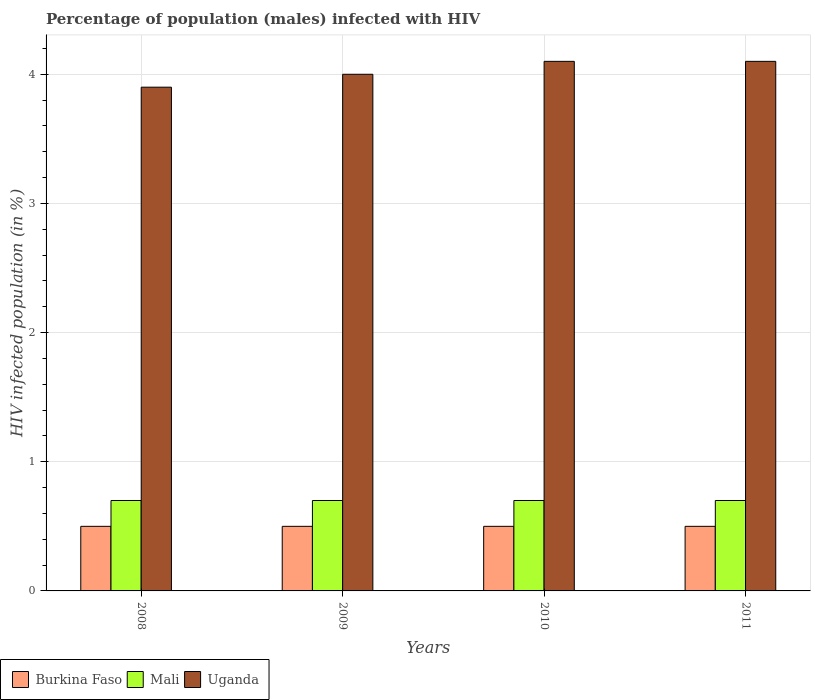How many different coloured bars are there?
Offer a terse response. 3. What is the label of the 3rd group of bars from the left?
Make the answer very short. 2010. In how many cases, is the number of bars for a given year not equal to the number of legend labels?
Provide a short and direct response. 0. What is the percentage of HIV infected male population in Uganda in 2008?
Offer a terse response. 3.9. Across all years, what is the maximum percentage of HIV infected male population in Burkina Faso?
Your answer should be compact. 0.5. What is the total percentage of HIV infected male population in Burkina Faso in the graph?
Make the answer very short. 2. What is the difference between the percentage of HIV infected male population in Burkina Faso in 2008 and the percentage of HIV infected male population in Uganda in 2010?
Make the answer very short. -3.6. What is the average percentage of HIV infected male population in Mali per year?
Offer a very short reply. 0.7. In the year 2010, what is the difference between the percentage of HIV infected male population in Burkina Faso and percentage of HIV infected male population in Mali?
Provide a succinct answer. -0.2. Is the percentage of HIV infected male population in Uganda in 2009 less than that in 2011?
Your answer should be compact. Yes. Is the difference between the percentage of HIV infected male population in Burkina Faso in 2010 and 2011 greater than the difference between the percentage of HIV infected male population in Mali in 2010 and 2011?
Offer a terse response. No. In how many years, is the percentage of HIV infected male population in Mali greater than the average percentage of HIV infected male population in Mali taken over all years?
Make the answer very short. 0. Is the sum of the percentage of HIV infected male population in Burkina Faso in 2009 and 2010 greater than the maximum percentage of HIV infected male population in Mali across all years?
Your answer should be very brief. Yes. What does the 1st bar from the left in 2009 represents?
Your answer should be compact. Burkina Faso. What does the 3rd bar from the right in 2011 represents?
Ensure brevity in your answer.  Burkina Faso. How many bars are there?
Provide a short and direct response. 12. Are all the bars in the graph horizontal?
Give a very brief answer. No. Does the graph contain any zero values?
Provide a short and direct response. No. Does the graph contain grids?
Keep it short and to the point. Yes. How many legend labels are there?
Your answer should be compact. 3. What is the title of the graph?
Make the answer very short. Percentage of population (males) infected with HIV. What is the label or title of the X-axis?
Offer a very short reply. Years. What is the label or title of the Y-axis?
Offer a terse response. HIV infected population (in %). What is the HIV infected population (in %) of Mali in 2008?
Make the answer very short. 0.7. What is the HIV infected population (in %) of Uganda in 2008?
Make the answer very short. 3.9. What is the HIV infected population (in %) in Burkina Faso in 2009?
Make the answer very short. 0.5. What is the HIV infected population (in %) in Mali in 2009?
Keep it short and to the point. 0.7. What is the HIV infected population (in %) in Uganda in 2009?
Provide a succinct answer. 4. What is the HIV infected population (in %) of Mali in 2010?
Offer a terse response. 0.7. What is the HIV infected population (in %) in Uganda in 2010?
Offer a very short reply. 4.1. What is the HIV infected population (in %) in Uganda in 2011?
Offer a terse response. 4.1. Across all years, what is the maximum HIV infected population (in %) of Burkina Faso?
Make the answer very short. 0.5. Across all years, what is the maximum HIV infected population (in %) in Mali?
Your answer should be compact. 0.7. Across all years, what is the minimum HIV infected population (in %) of Uganda?
Your answer should be very brief. 3.9. What is the total HIV infected population (in %) of Burkina Faso in the graph?
Provide a short and direct response. 2. What is the difference between the HIV infected population (in %) in Uganda in 2008 and that in 2009?
Provide a succinct answer. -0.1. What is the difference between the HIV infected population (in %) in Mali in 2008 and that in 2010?
Your answer should be very brief. 0. What is the difference between the HIV infected population (in %) of Uganda in 2008 and that in 2010?
Your answer should be compact. -0.2. What is the difference between the HIV infected population (in %) of Mali in 2008 and that in 2011?
Your response must be concise. 0. What is the difference between the HIV infected population (in %) of Uganda in 2008 and that in 2011?
Make the answer very short. -0.2. What is the difference between the HIV infected population (in %) of Burkina Faso in 2009 and that in 2010?
Provide a short and direct response. 0. What is the difference between the HIV infected population (in %) of Mali in 2009 and that in 2010?
Ensure brevity in your answer.  0. What is the difference between the HIV infected population (in %) in Uganda in 2009 and that in 2010?
Your answer should be compact. -0.1. What is the difference between the HIV infected population (in %) in Uganda in 2010 and that in 2011?
Make the answer very short. 0. What is the difference between the HIV infected population (in %) in Burkina Faso in 2008 and the HIV infected population (in %) in Mali in 2009?
Your answer should be compact. -0.2. What is the difference between the HIV infected population (in %) of Mali in 2008 and the HIV infected population (in %) of Uganda in 2009?
Give a very brief answer. -3.3. What is the difference between the HIV infected population (in %) of Burkina Faso in 2008 and the HIV infected population (in %) of Uganda in 2011?
Ensure brevity in your answer.  -3.6. What is the difference between the HIV infected population (in %) in Burkina Faso in 2009 and the HIV infected population (in %) in Mali in 2011?
Keep it short and to the point. -0.2. What is the difference between the HIV infected population (in %) of Burkina Faso in 2009 and the HIV infected population (in %) of Uganda in 2011?
Your answer should be compact. -3.6. What is the average HIV infected population (in %) in Uganda per year?
Make the answer very short. 4.03. In the year 2010, what is the difference between the HIV infected population (in %) in Mali and HIV infected population (in %) in Uganda?
Offer a terse response. -3.4. In the year 2011, what is the difference between the HIV infected population (in %) in Burkina Faso and HIV infected population (in %) in Mali?
Give a very brief answer. -0.2. In the year 2011, what is the difference between the HIV infected population (in %) in Mali and HIV infected population (in %) in Uganda?
Your answer should be compact. -3.4. What is the ratio of the HIV infected population (in %) in Burkina Faso in 2008 to that in 2009?
Your answer should be very brief. 1. What is the ratio of the HIV infected population (in %) in Mali in 2008 to that in 2009?
Keep it short and to the point. 1. What is the ratio of the HIV infected population (in %) of Uganda in 2008 to that in 2009?
Keep it short and to the point. 0.97. What is the ratio of the HIV infected population (in %) of Burkina Faso in 2008 to that in 2010?
Your answer should be very brief. 1. What is the ratio of the HIV infected population (in %) of Mali in 2008 to that in 2010?
Give a very brief answer. 1. What is the ratio of the HIV infected population (in %) in Uganda in 2008 to that in 2010?
Provide a succinct answer. 0.95. What is the ratio of the HIV infected population (in %) in Mali in 2008 to that in 2011?
Offer a very short reply. 1. What is the ratio of the HIV infected population (in %) in Uganda in 2008 to that in 2011?
Your answer should be compact. 0.95. What is the ratio of the HIV infected population (in %) of Uganda in 2009 to that in 2010?
Make the answer very short. 0.98. What is the ratio of the HIV infected population (in %) in Mali in 2009 to that in 2011?
Your answer should be very brief. 1. What is the ratio of the HIV infected population (in %) of Uganda in 2009 to that in 2011?
Provide a succinct answer. 0.98. What is the ratio of the HIV infected population (in %) of Burkina Faso in 2010 to that in 2011?
Offer a terse response. 1. What is the ratio of the HIV infected population (in %) of Uganda in 2010 to that in 2011?
Give a very brief answer. 1. What is the difference between the highest and the second highest HIV infected population (in %) in Burkina Faso?
Your answer should be very brief. 0. What is the difference between the highest and the second highest HIV infected population (in %) in Mali?
Offer a terse response. 0. What is the difference between the highest and the lowest HIV infected population (in %) in Mali?
Provide a succinct answer. 0. 